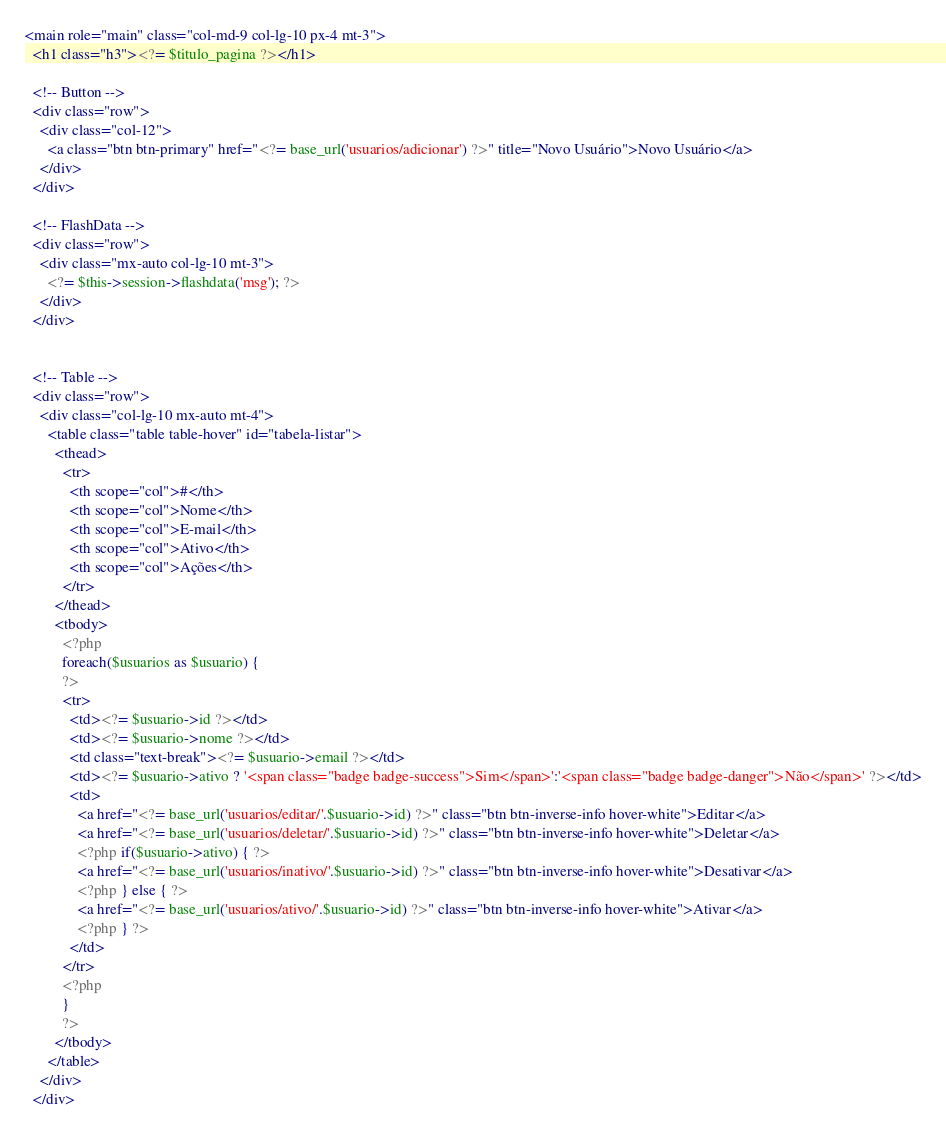<code> <loc_0><loc_0><loc_500><loc_500><_PHP_><main role="main" class="col-md-9 col-lg-10 px-4 mt-3">
  <h1 class="h3"><?= $titulo_pagina ?></h1>

  <!-- Button -->
  <div class="row">
    <div class="col-12">
      <a class="btn btn-primary" href="<?= base_url('usuarios/adicionar') ?>" title="Novo Usuário">Novo Usuário</a>
    </div>  
  </div>  

  <!-- FlashData -->
  <div class="row">
    <div class="mx-auto col-lg-10 mt-3">
      <?= $this->session->flashdata('msg'); ?>
    </div>  
  </div>  


  <!-- Table -->
  <div class="row">
    <div class="col-lg-10 mx-auto mt-4">
      <table class="table table-hover" id="tabela-listar">
        <thead>
          <tr>
            <th scope="col">#</th>
            <th scope="col">Nome</th>
            <th scope="col">E-mail</th>
            <th scope="col">Ativo</th>
            <th scope="col">Ações</th>
          </tr>
        </thead>
        <tbody> 
          <?php
          foreach($usuarios as $usuario) {
          ?>
          <tr>
            <td><?= $usuario->id ?></td>
            <td><?= $usuario->nome ?></td>
            <td class="text-break"><?= $usuario->email ?></td>
            <td><?= $usuario->ativo ? '<span class="badge badge-success">Sim</span>':'<span class="badge badge-danger">Não</span>' ?></td>
            <td>
              <a href="<?= base_url('usuarios/editar/'.$usuario->id) ?>" class="btn btn-inverse-info hover-white">Editar</a>
              <a href="<?= base_url('usuarios/deletar/'.$usuario->id) ?>" class="btn btn-inverse-info hover-white">Deletar</a>
              <?php if($usuario->ativo) { ?>
              <a href="<?= base_url('usuarios/inativo/'.$usuario->id) ?>" class="btn btn-inverse-info hover-white">Desativar</a>    
              <?php } else { ?>
              <a href="<?= base_url('usuarios/ativo/'.$usuario->id) ?>" class="btn btn-inverse-info hover-white">Ativar</a>      
              <?php } ?>
            </td>
          </tr>
          <?php  
          } 
          ?>      
        </tbody>
      </table>
    </div>
  </div></code> 